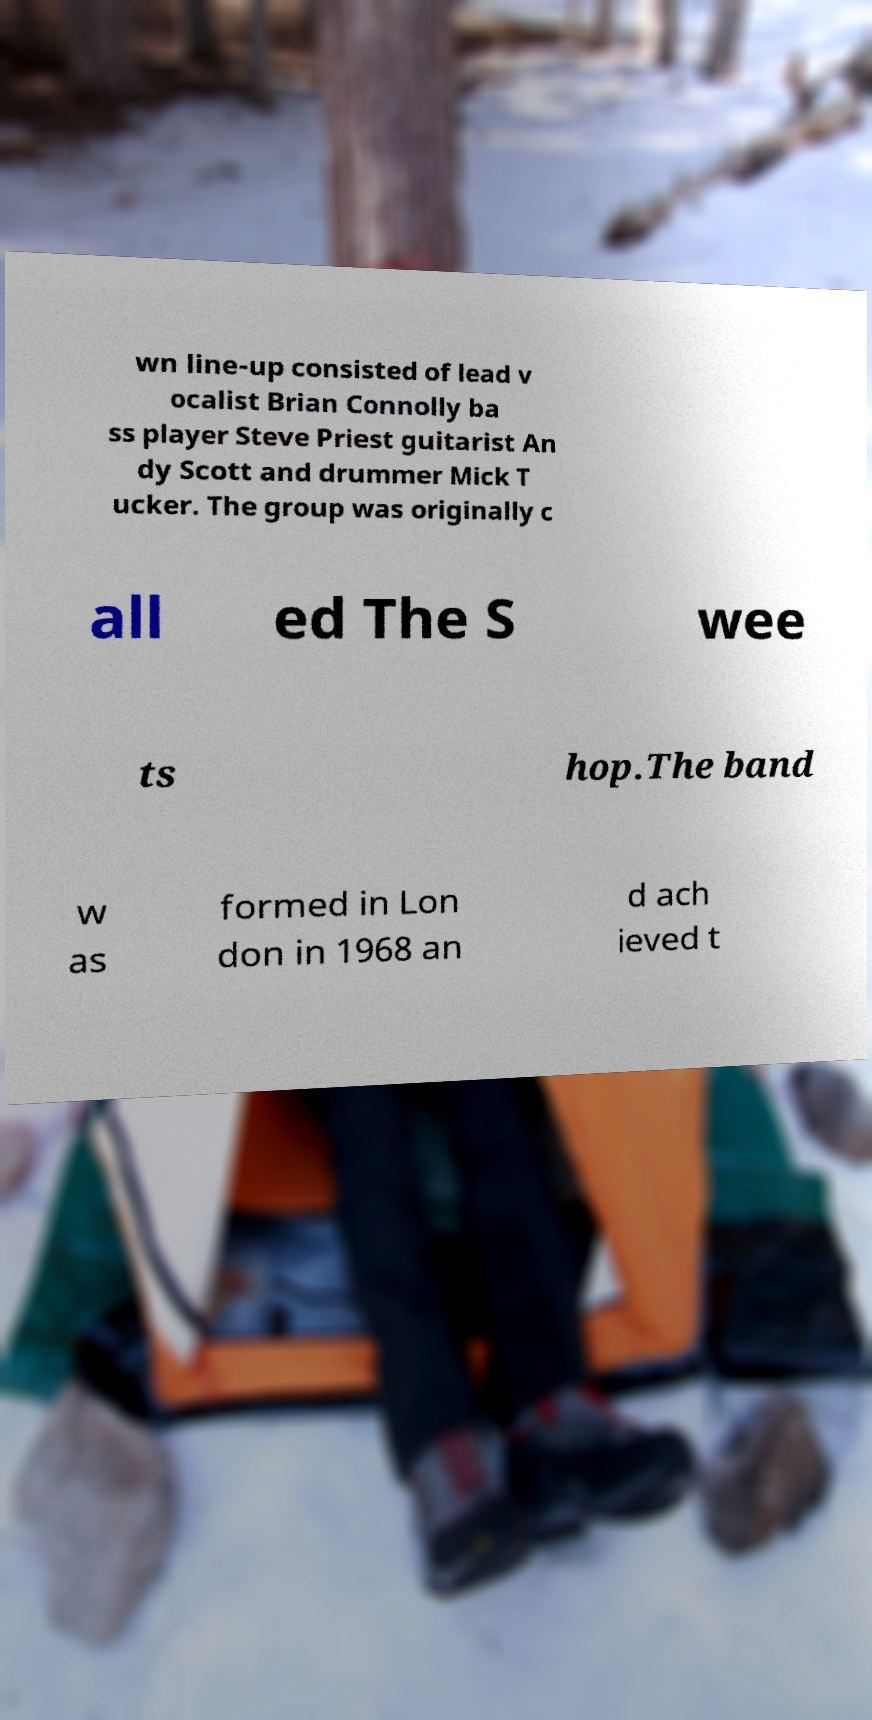Could you assist in decoding the text presented in this image and type it out clearly? wn line-up consisted of lead v ocalist Brian Connolly ba ss player Steve Priest guitarist An dy Scott and drummer Mick T ucker. The group was originally c all ed The S wee ts hop.The band w as formed in Lon don in 1968 an d ach ieved t 